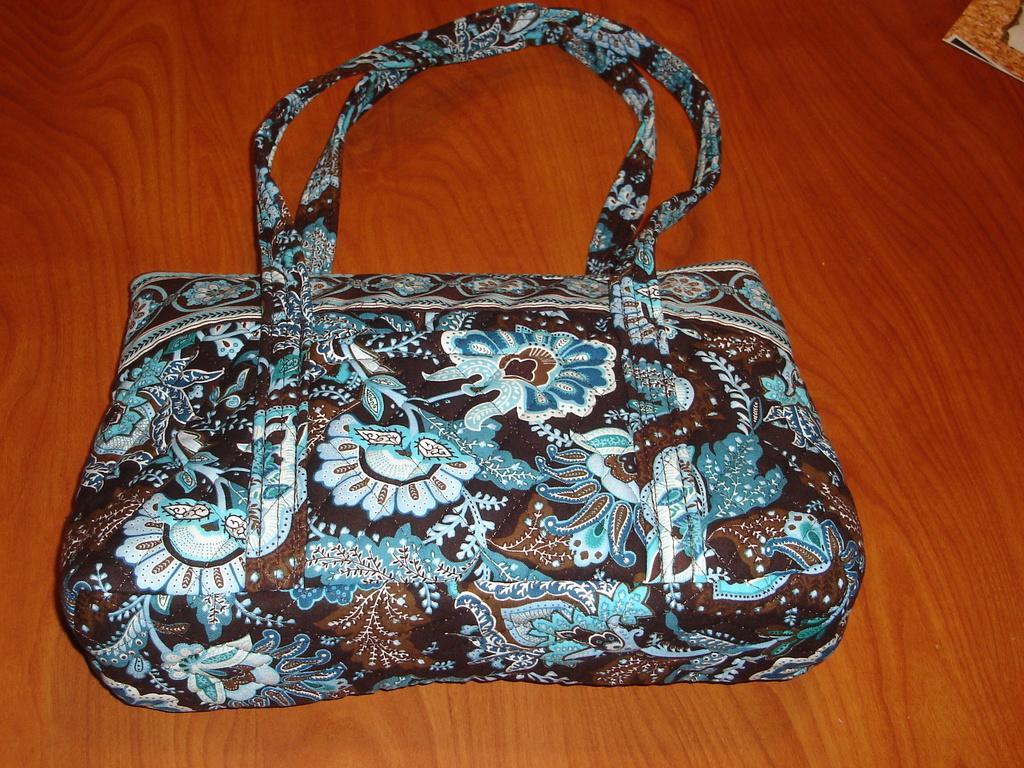How would you summarize this image in a sentence or two? In this picture we have a table on the table a bag is placed on the corner of the picture we can see a book. 